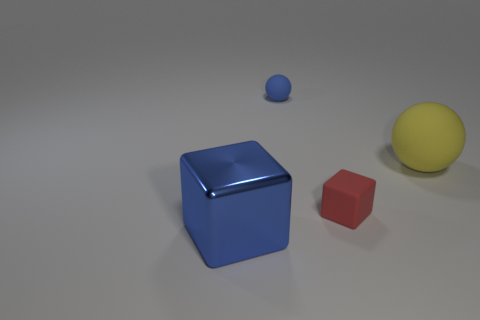Add 1 tiny red things. How many objects exist? 5 Add 3 large yellow spheres. How many large yellow spheres are left? 4 Add 1 small blue objects. How many small blue objects exist? 2 Subtract 1 yellow spheres. How many objects are left? 3 Subtract all large red metallic objects. Subtract all yellow matte things. How many objects are left? 3 